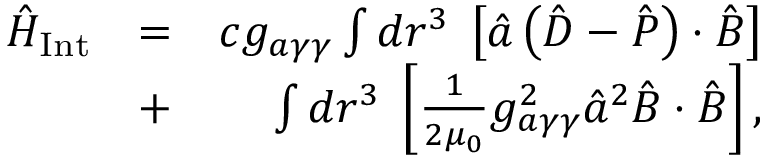Convert formula to latex. <formula><loc_0><loc_0><loc_500><loc_500>\begin{array} { r l r } { \hat { H } _ { I n t } } & { = } & { c g _ { a \gamma \gamma } \int d \boldsymbol r ^ { 3 } \, \left [ \hat { a } \left ( \hat { \boldsymbol D } - \hat { \boldsymbol P } \right ) \cdot \hat { \boldsymbol B } \right ] } \\ & { + } & { \int d \boldsymbol r ^ { 3 } \, \left [ \frac { 1 } { 2 \mu _ { 0 } } g _ { a \gamma \gamma } ^ { 2 } \hat { a } ^ { 2 } \hat { \boldsymbol B } \cdot \hat { \boldsymbol B } \right ] , } \end{array}</formula> 